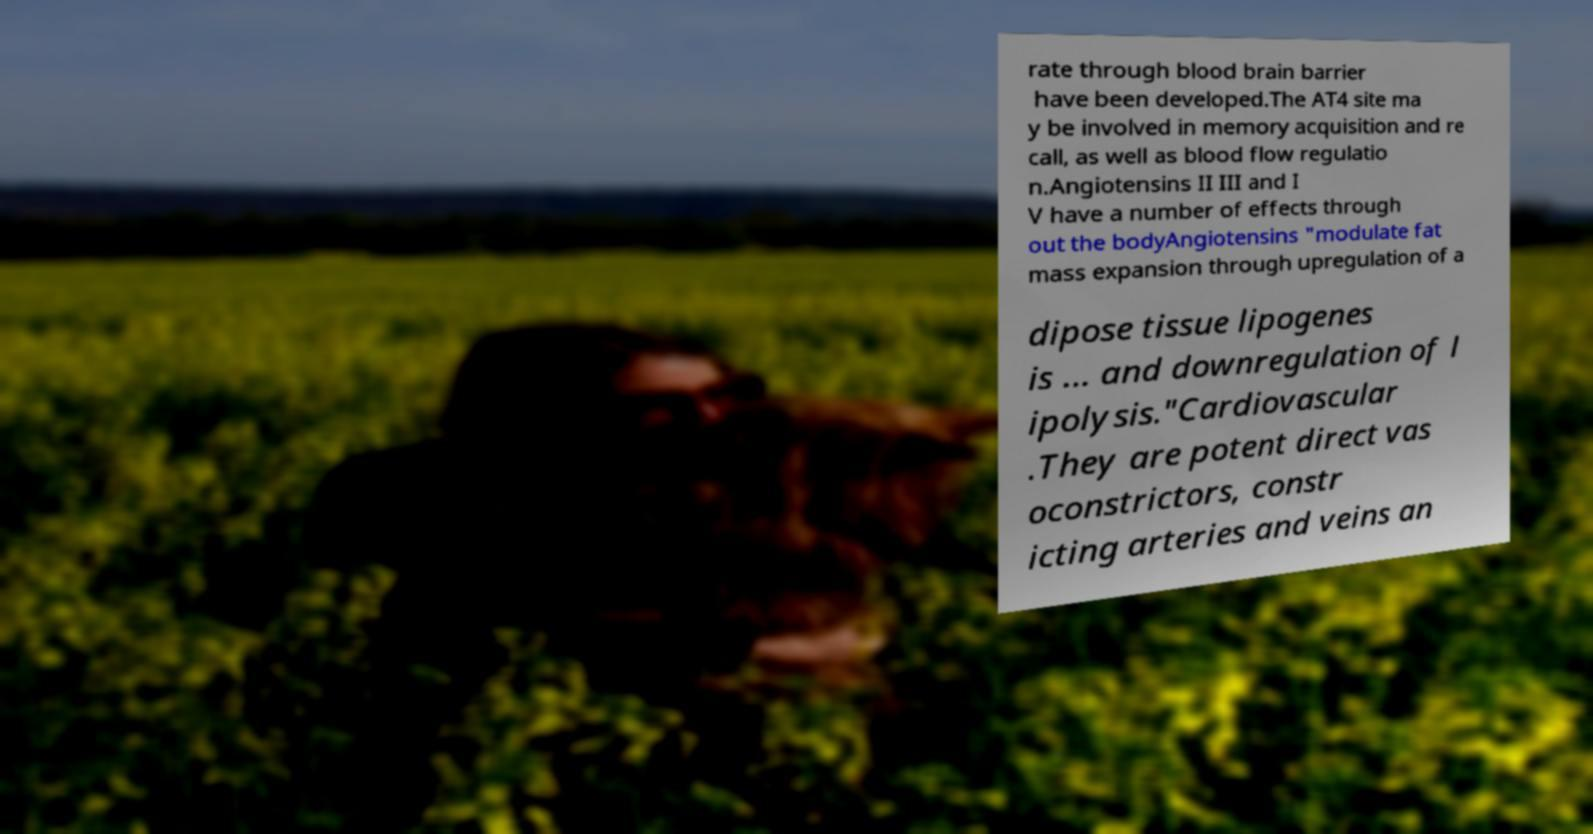For documentation purposes, I need the text within this image transcribed. Could you provide that? rate through blood brain barrier have been developed.The AT4 site ma y be involved in memory acquisition and re call, as well as blood flow regulatio n.Angiotensins II III and I V have a number of effects through out the bodyAngiotensins "modulate fat mass expansion through upregulation of a dipose tissue lipogenes is ... and downregulation of l ipolysis."Cardiovascular .They are potent direct vas oconstrictors, constr icting arteries and veins an 